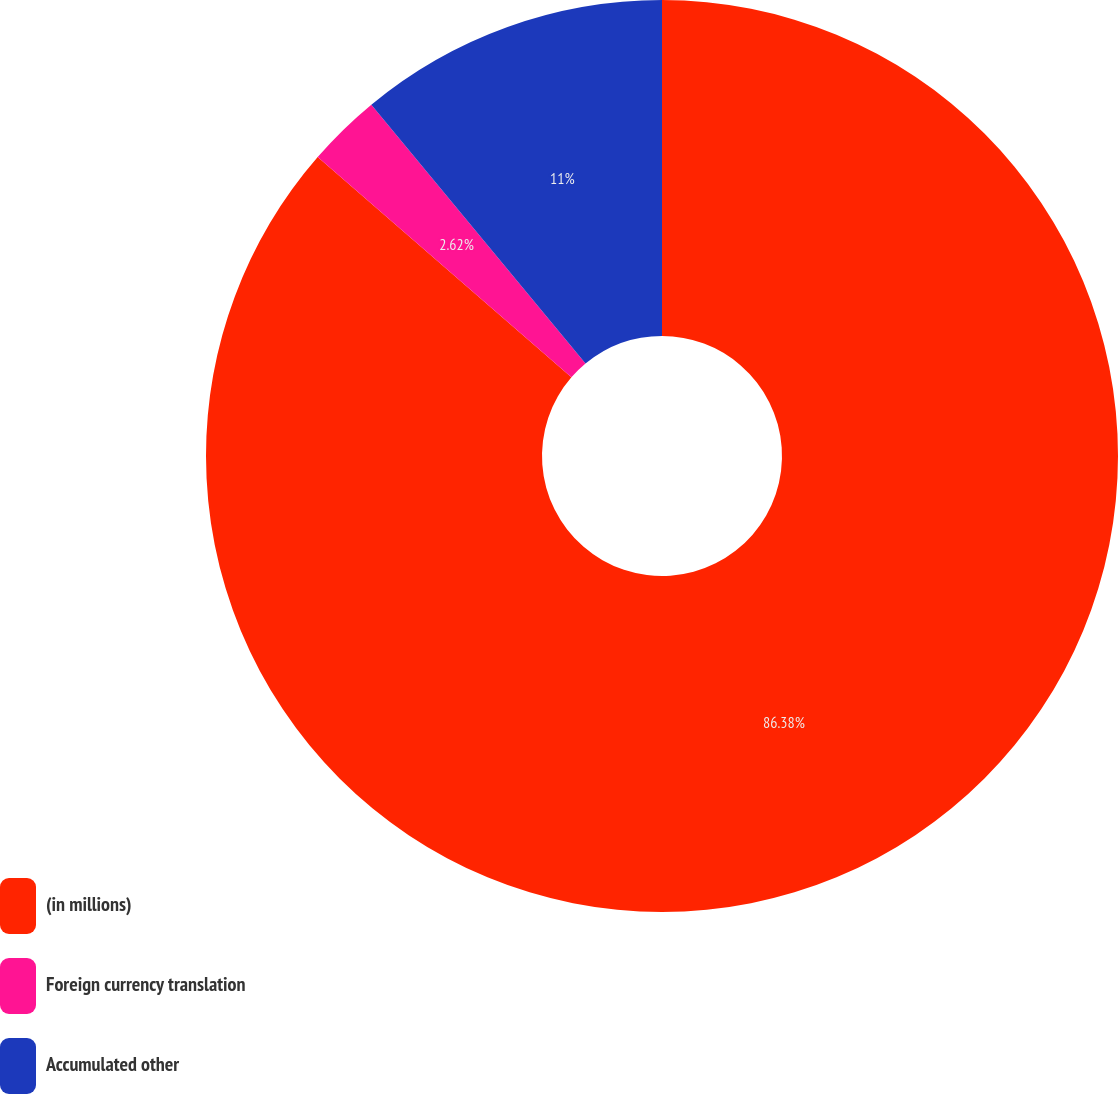<chart> <loc_0><loc_0><loc_500><loc_500><pie_chart><fcel>(in millions)<fcel>Foreign currency translation<fcel>Accumulated other<nl><fcel>86.38%<fcel>2.62%<fcel>11.0%<nl></chart> 